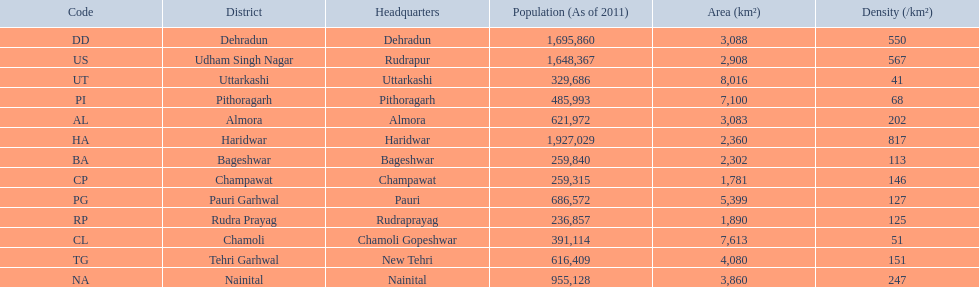What is the total amount of districts listed? 13. 